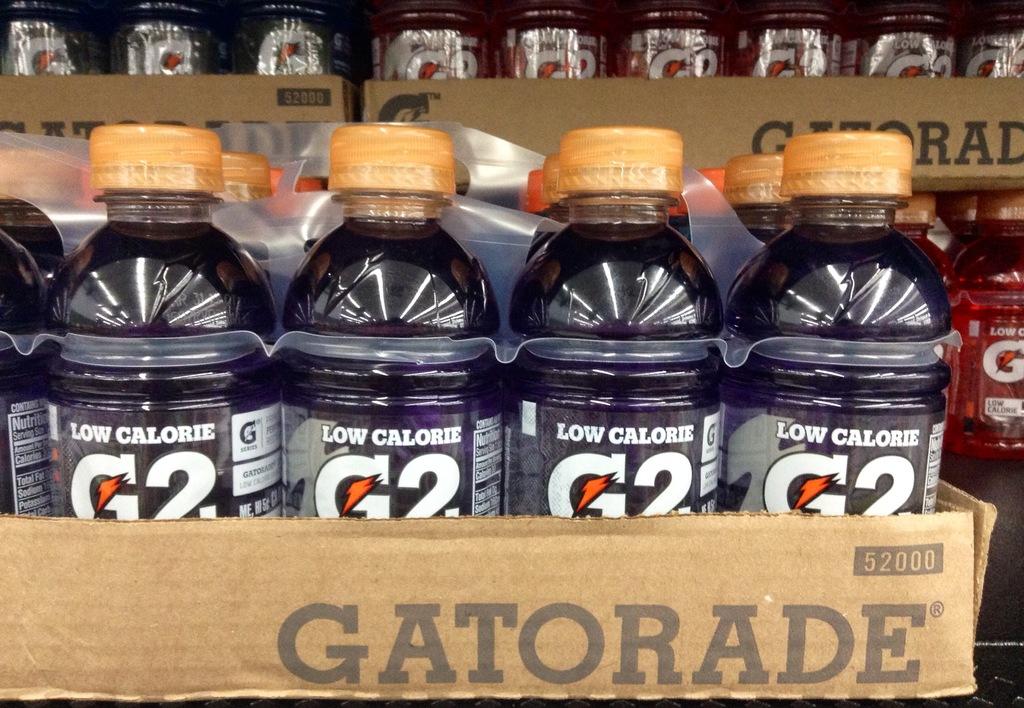What is the brand name of the drink?
Give a very brief answer. Gatorade. How many calories are the beverages?
Your answer should be very brief. Low. 